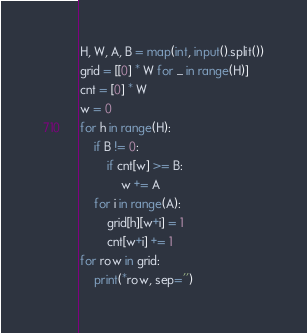<code> <loc_0><loc_0><loc_500><loc_500><_Python_>H, W, A, B = map(int, input().split())
grid = [[0] * W for _ in range(H)]
cnt = [0] * W
w = 0
for h in range(H):
    if B != 0:
        if cnt[w] >= B:
            w += A
    for i in range(A):
        grid[h][w+i] = 1
        cnt[w+i] += 1
for row in grid:
    print(*row, sep='')
</code> 